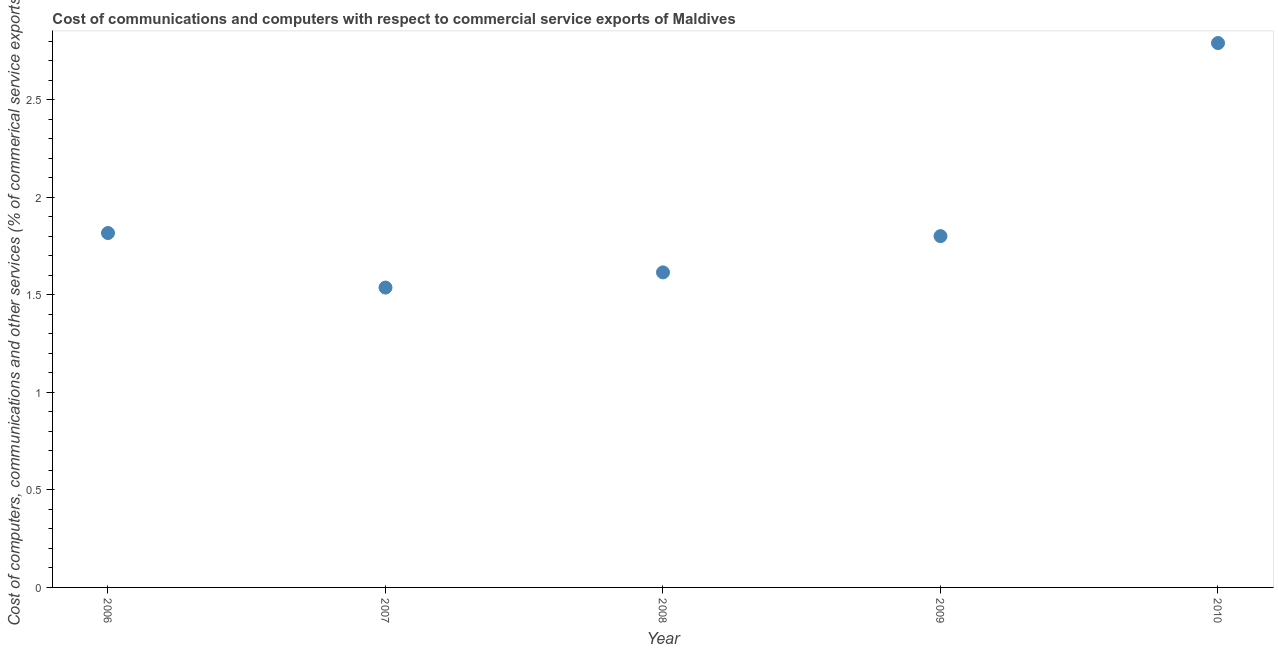What is the  computer and other services in 2008?
Your response must be concise. 1.61. Across all years, what is the maximum cost of communications?
Make the answer very short. 2.79. Across all years, what is the minimum cost of communications?
Make the answer very short. 1.54. What is the sum of the  computer and other services?
Your answer should be very brief. 9.56. What is the difference between the  computer and other services in 2006 and 2010?
Your answer should be very brief. -0.97. What is the average cost of communications per year?
Give a very brief answer. 1.91. What is the median  computer and other services?
Ensure brevity in your answer.  1.8. In how many years, is the cost of communications greater than 2.6 %?
Your answer should be very brief. 1. Do a majority of the years between 2009 and 2007 (inclusive) have cost of communications greater than 1.1 %?
Your answer should be very brief. No. What is the ratio of the cost of communications in 2007 to that in 2008?
Keep it short and to the point. 0.95. Is the  computer and other services in 2007 less than that in 2009?
Provide a short and direct response. Yes. Is the difference between the  computer and other services in 2009 and 2010 greater than the difference between any two years?
Give a very brief answer. No. What is the difference between the highest and the second highest  computer and other services?
Give a very brief answer. 0.97. What is the difference between the highest and the lowest cost of communications?
Make the answer very short. 1.25. In how many years, is the cost of communications greater than the average cost of communications taken over all years?
Offer a terse response. 1. How many dotlines are there?
Your response must be concise. 1. Does the graph contain any zero values?
Offer a terse response. No. Does the graph contain grids?
Offer a very short reply. No. What is the title of the graph?
Ensure brevity in your answer.  Cost of communications and computers with respect to commercial service exports of Maldives. What is the label or title of the X-axis?
Keep it short and to the point. Year. What is the label or title of the Y-axis?
Provide a short and direct response. Cost of computers, communications and other services (% of commerical service exports). What is the Cost of computers, communications and other services (% of commerical service exports) in 2006?
Ensure brevity in your answer.  1.82. What is the Cost of computers, communications and other services (% of commerical service exports) in 2007?
Offer a terse response. 1.54. What is the Cost of computers, communications and other services (% of commerical service exports) in 2008?
Your answer should be compact. 1.61. What is the Cost of computers, communications and other services (% of commerical service exports) in 2009?
Offer a terse response. 1.8. What is the Cost of computers, communications and other services (% of commerical service exports) in 2010?
Provide a succinct answer. 2.79. What is the difference between the Cost of computers, communications and other services (% of commerical service exports) in 2006 and 2007?
Offer a very short reply. 0.28. What is the difference between the Cost of computers, communications and other services (% of commerical service exports) in 2006 and 2008?
Your response must be concise. 0.2. What is the difference between the Cost of computers, communications and other services (% of commerical service exports) in 2006 and 2009?
Ensure brevity in your answer.  0.02. What is the difference between the Cost of computers, communications and other services (% of commerical service exports) in 2006 and 2010?
Provide a short and direct response. -0.97. What is the difference between the Cost of computers, communications and other services (% of commerical service exports) in 2007 and 2008?
Provide a short and direct response. -0.08. What is the difference between the Cost of computers, communications and other services (% of commerical service exports) in 2007 and 2009?
Give a very brief answer. -0.26. What is the difference between the Cost of computers, communications and other services (% of commerical service exports) in 2007 and 2010?
Keep it short and to the point. -1.25. What is the difference between the Cost of computers, communications and other services (% of commerical service exports) in 2008 and 2009?
Your response must be concise. -0.19. What is the difference between the Cost of computers, communications and other services (% of commerical service exports) in 2008 and 2010?
Offer a very short reply. -1.18. What is the difference between the Cost of computers, communications and other services (% of commerical service exports) in 2009 and 2010?
Your response must be concise. -0.99. What is the ratio of the Cost of computers, communications and other services (% of commerical service exports) in 2006 to that in 2007?
Give a very brief answer. 1.18. What is the ratio of the Cost of computers, communications and other services (% of commerical service exports) in 2006 to that in 2009?
Give a very brief answer. 1.01. What is the ratio of the Cost of computers, communications and other services (% of commerical service exports) in 2006 to that in 2010?
Make the answer very short. 0.65. What is the ratio of the Cost of computers, communications and other services (% of commerical service exports) in 2007 to that in 2009?
Provide a short and direct response. 0.85. What is the ratio of the Cost of computers, communications and other services (% of commerical service exports) in 2007 to that in 2010?
Ensure brevity in your answer.  0.55. What is the ratio of the Cost of computers, communications and other services (% of commerical service exports) in 2008 to that in 2009?
Offer a very short reply. 0.9. What is the ratio of the Cost of computers, communications and other services (% of commerical service exports) in 2008 to that in 2010?
Offer a very short reply. 0.58. What is the ratio of the Cost of computers, communications and other services (% of commerical service exports) in 2009 to that in 2010?
Ensure brevity in your answer.  0.65. 